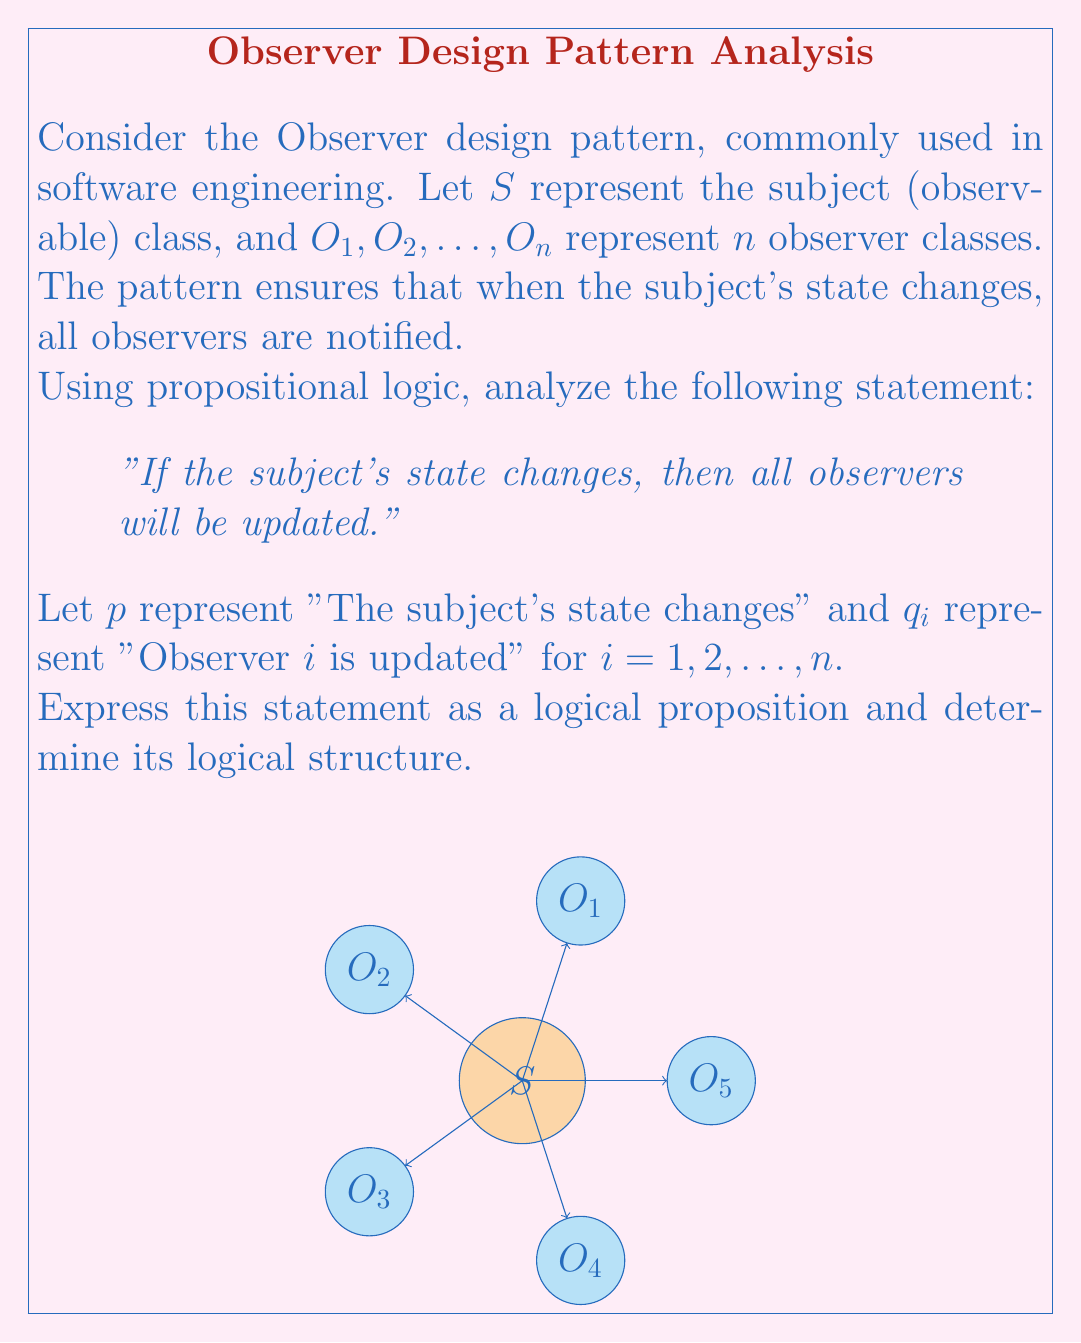Could you help me with this problem? Let's approach this step-by-step:

1) First, we need to translate the statement into propositional logic. The statement "If the subject's state changes, then all observers will be updated" can be represented as:

   $p \implies (q_1 \wedge q_2 \wedge ... \wedge q_n)$

2) This proposition has the structure of an implication $(P \implies Q)$, where:
   $P = p$ (The subject's state changes)
   $Q = (q_1 \wedge q_2 \wedge ... \wedge q_n)$ (All observers are updated)

3) The right-hand side of the implication $(q_1 \wedge q_2 \wedge ... \wedge q_n)$ is a conjunction of $n$ propositions, representing that all observers must be updated.

4) In propositional logic, an implication $P \implies Q$ is logically equivalent to $\neg P \vee Q$. Therefore, our statement can also be written as:

   $\neg p \vee (q_1 \wedge q_2 \wedge ... \wedge q_n)$

5) Using De Morgan's laws, we can further transform this to:

   $\neg p \vee q_1) \wedge (\neg p \vee q_2) \wedge ... \wedge (\neg p \vee q_n)$

6) This final form represents a conjunction of $n$ disjunctions, each ensuring that either the subject's state doesn't change, or the respective observer is updated.

7) In the context of the Observer pattern, this logical structure ensures that when the subject's state changes $(p)$, each observer $(q_i)$ must be updated, maintaining the consistency between the subject and its observers.
Answer: $p \implies (q_1 \wedge q_2 \wedge ... \wedge q_n)$, equivalent to $(\neg p \vee q_1) \wedge (\neg p \vee q_2) \wedge ... \wedge (\neg p \vee q_n)$ 